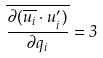Convert formula to latex. <formula><loc_0><loc_0><loc_500><loc_500>\overline { \frac { \partial ( \overline { u _ { i } } \cdot u _ { i } ^ { \prime } ) } { \partial q _ { i } } } = 3</formula> 